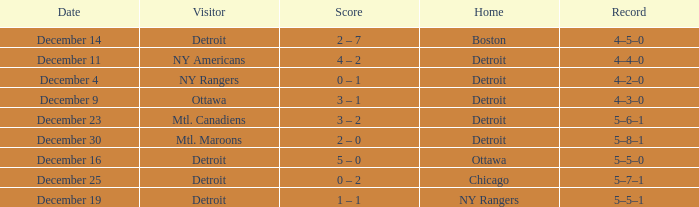What score has mtl. maroons as the visitor? 2 – 0. 